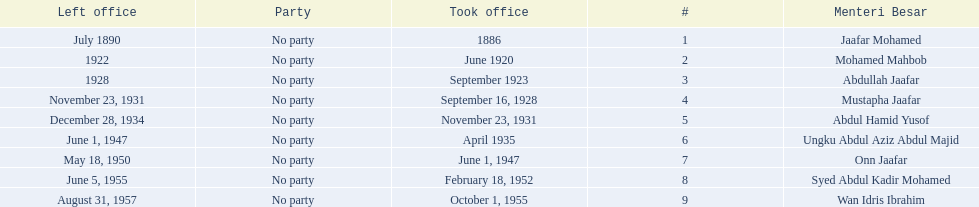What are all the people that were menteri besar of johor? Jaafar Mohamed, Mohamed Mahbob, Abdullah Jaafar, Mustapha Jaafar, Abdul Hamid Yusof, Ungku Abdul Aziz Abdul Majid, Onn Jaafar, Syed Abdul Kadir Mohamed, Wan Idris Ibrahim. Who ruled the longest? Ungku Abdul Aziz Abdul Majid. 